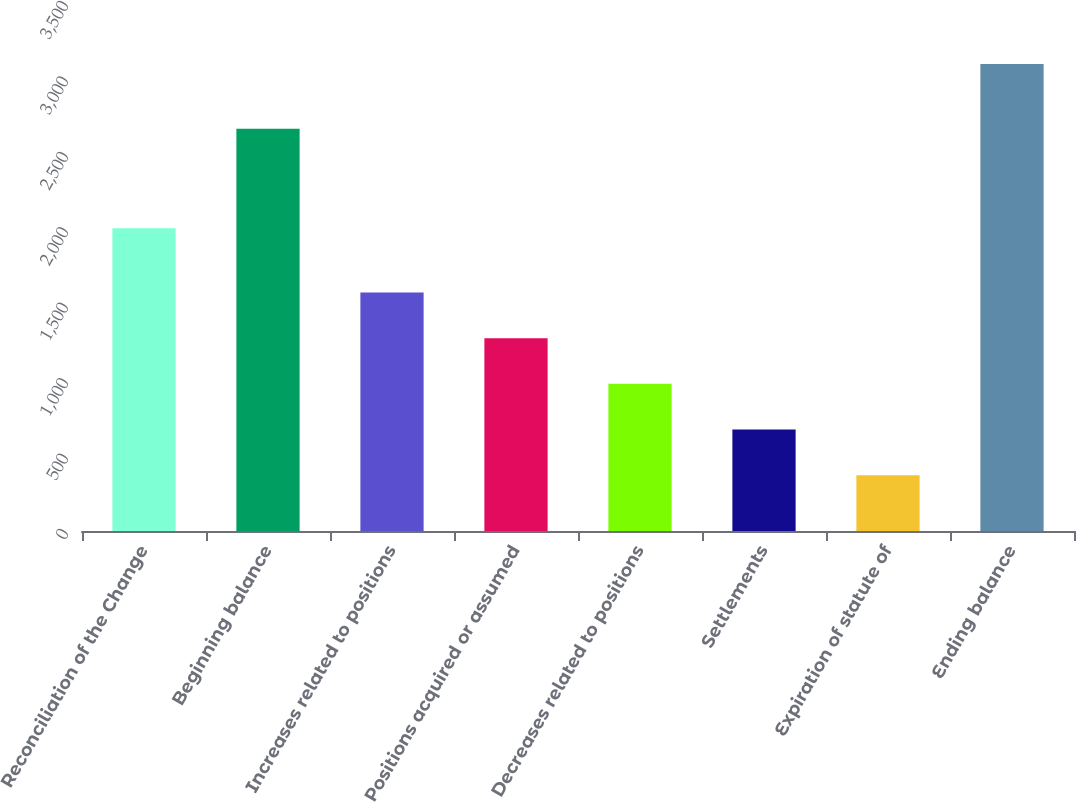Convert chart to OTSL. <chart><loc_0><loc_0><loc_500><loc_500><bar_chart><fcel>Reconciliation of the Change<fcel>Beginning balance<fcel>Increases related to positions<fcel>Positions acquired or assumed<fcel>Decreases related to positions<fcel>Settlements<fcel>Expiration of statute of<fcel>Ending balance<nl><fcel>2007<fcel>2667<fcel>1581<fcel>1278.2<fcel>975.4<fcel>672.6<fcel>369.8<fcel>3095<nl></chart> 